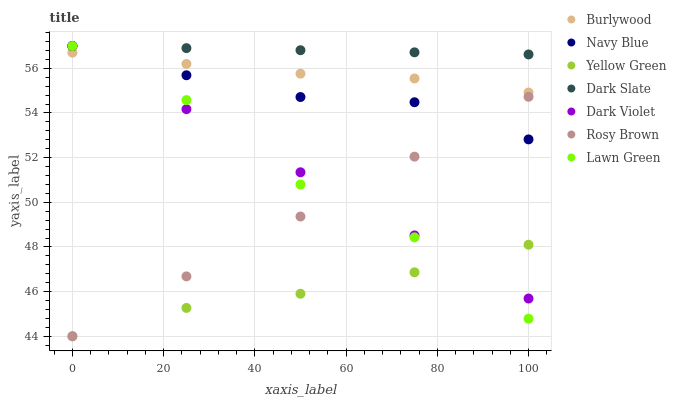Does Yellow Green have the minimum area under the curve?
Answer yes or no. Yes. Does Dark Slate have the maximum area under the curve?
Answer yes or no. Yes. Does Burlywood have the minimum area under the curve?
Answer yes or no. No. Does Burlywood have the maximum area under the curve?
Answer yes or no. No. Is Rosy Brown the smoothest?
Answer yes or no. Yes. Is Lawn Green the roughest?
Answer yes or no. Yes. Is Yellow Green the smoothest?
Answer yes or no. No. Is Yellow Green the roughest?
Answer yes or no. No. Does Yellow Green have the lowest value?
Answer yes or no. Yes. Does Burlywood have the lowest value?
Answer yes or no. No. Does Dark Slate have the highest value?
Answer yes or no. Yes. Does Burlywood have the highest value?
Answer yes or no. No. Is Yellow Green less than Navy Blue?
Answer yes or no. Yes. Is Dark Slate greater than Yellow Green?
Answer yes or no. Yes. Does Lawn Green intersect Burlywood?
Answer yes or no. Yes. Is Lawn Green less than Burlywood?
Answer yes or no. No. Is Lawn Green greater than Burlywood?
Answer yes or no. No. Does Yellow Green intersect Navy Blue?
Answer yes or no. No. 